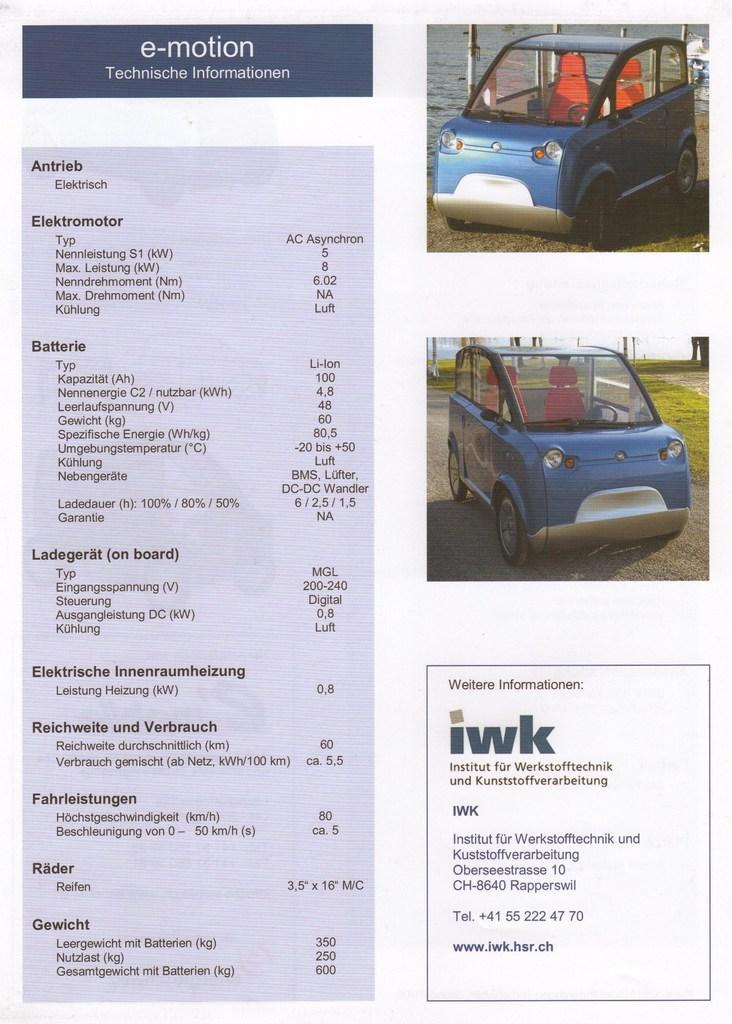Could you give a brief overview of what you see in this image? In this picture there is a poster. On the left of the poster I can see the equipment names. On the right there is an electric car which is parked near to the grass. Behind the car I can see the water, sky and fencing. In the top right I can see the same car which is parked near to the fencing and water. In the bottom right I can see the company's address. 